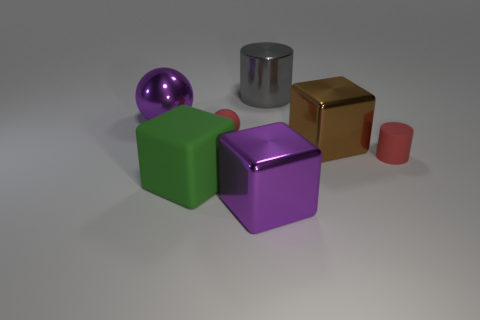Subtract all shiny blocks. How many blocks are left? 1 Add 3 small balls. How many objects exist? 10 Subtract all cubes. How many objects are left? 4 Subtract 2 cubes. How many cubes are left? 1 Subtract all purple cubes. How many cubes are left? 2 Subtract all purple spheres. How many green cubes are left? 1 Subtract all red spheres. Subtract all brown cylinders. How many spheres are left? 1 Subtract all gray objects. Subtract all gray metallic cylinders. How many objects are left? 5 Add 6 large brown shiny cubes. How many large brown shiny cubes are left? 7 Add 5 gray things. How many gray things exist? 6 